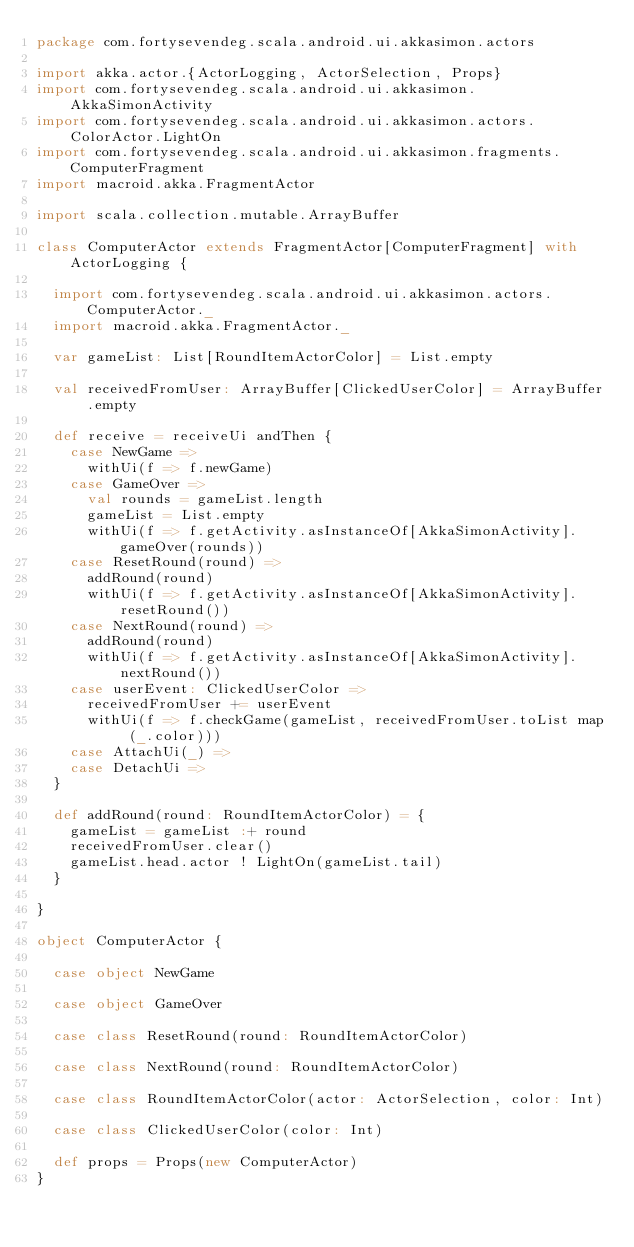Convert code to text. <code><loc_0><loc_0><loc_500><loc_500><_Scala_>package com.fortysevendeg.scala.android.ui.akkasimon.actors

import akka.actor.{ActorLogging, ActorSelection, Props}
import com.fortysevendeg.scala.android.ui.akkasimon.AkkaSimonActivity
import com.fortysevendeg.scala.android.ui.akkasimon.actors.ColorActor.LightOn
import com.fortysevendeg.scala.android.ui.akkasimon.fragments.ComputerFragment
import macroid.akka.FragmentActor

import scala.collection.mutable.ArrayBuffer

class ComputerActor extends FragmentActor[ComputerFragment] with ActorLogging {

  import com.fortysevendeg.scala.android.ui.akkasimon.actors.ComputerActor._
  import macroid.akka.FragmentActor._

  var gameList: List[RoundItemActorColor] = List.empty

  val receivedFromUser: ArrayBuffer[ClickedUserColor] = ArrayBuffer.empty

  def receive = receiveUi andThen {
    case NewGame =>
      withUi(f => f.newGame)
    case GameOver =>
      val rounds = gameList.length
      gameList = List.empty
      withUi(f => f.getActivity.asInstanceOf[AkkaSimonActivity].gameOver(rounds))
    case ResetRound(round) =>
      addRound(round)
      withUi(f => f.getActivity.asInstanceOf[AkkaSimonActivity].resetRound())
    case NextRound(round) =>
      addRound(round)
      withUi(f => f.getActivity.asInstanceOf[AkkaSimonActivity].nextRound())
    case userEvent: ClickedUserColor =>
      receivedFromUser += userEvent
      withUi(f => f.checkGame(gameList, receivedFromUser.toList map (_.color)))
    case AttachUi(_) =>
    case DetachUi =>
  }

  def addRound(round: RoundItemActorColor) = {
    gameList = gameList :+ round
    receivedFromUser.clear()
    gameList.head.actor ! LightOn(gameList.tail)
  }

}

object ComputerActor {

  case object NewGame

  case object GameOver

  case class ResetRound(round: RoundItemActorColor)

  case class NextRound(round: RoundItemActorColor)

  case class RoundItemActorColor(actor: ActorSelection, color: Int)

  case class ClickedUserColor(color: Int)

  def props = Props(new ComputerActor)
}</code> 